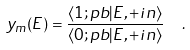Convert formula to latex. <formula><loc_0><loc_0><loc_500><loc_500>y _ { m } ( E ) = \frac { \langle 1 ; p b | E , + i n \rangle } { \langle 0 ; p b | E , + i n \rangle } \ \ .</formula> 